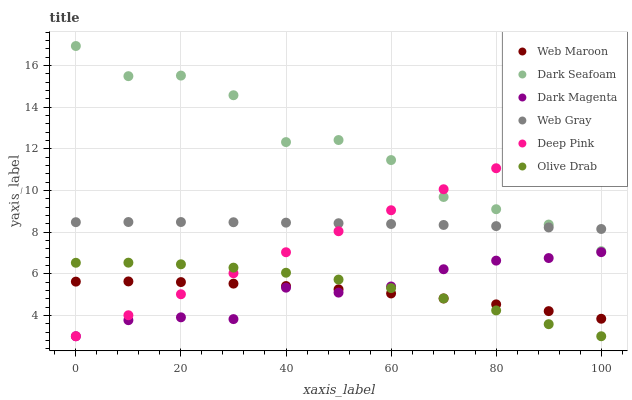Does Web Maroon have the minimum area under the curve?
Answer yes or no. Yes. Does Dark Seafoam have the maximum area under the curve?
Answer yes or no. Yes. Does Dark Magenta have the minimum area under the curve?
Answer yes or no. No. Does Dark Magenta have the maximum area under the curve?
Answer yes or no. No. Is Deep Pink the smoothest?
Answer yes or no. Yes. Is Dark Seafoam the roughest?
Answer yes or no. Yes. Is Dark Magenta the smoothest?
Answer yes or no. No. Is Dark Magenta the roughest?
Answer yes or no. No. Does Dark Magenta have the lowest value?
Answer yes or no. Yes. Does Web Maroon have the lowest value?
Answer yes or no. No. Does Dark Seafoam have the highest value?
Answer yes or no. Yes. Does Dark Magenta have the highest value?
Answer yes or no. No. Is Dark Magenta less than Web Gray?
Answer yes or no. Yes. Is Web Gray greater than Web Maroon?
Answer yes or no. Yes. Does Dark Magenta intersect Olive Drab?
Answer yes or no. Yes. Is Dark Magenta less than Olive Drab?
Answer yes or no. No. Is Dark Magenta greater than Olive Drab?
Answer yes or no. No. Does Dark Magenta intersect Web Gray?
Answer yes or no. No. 